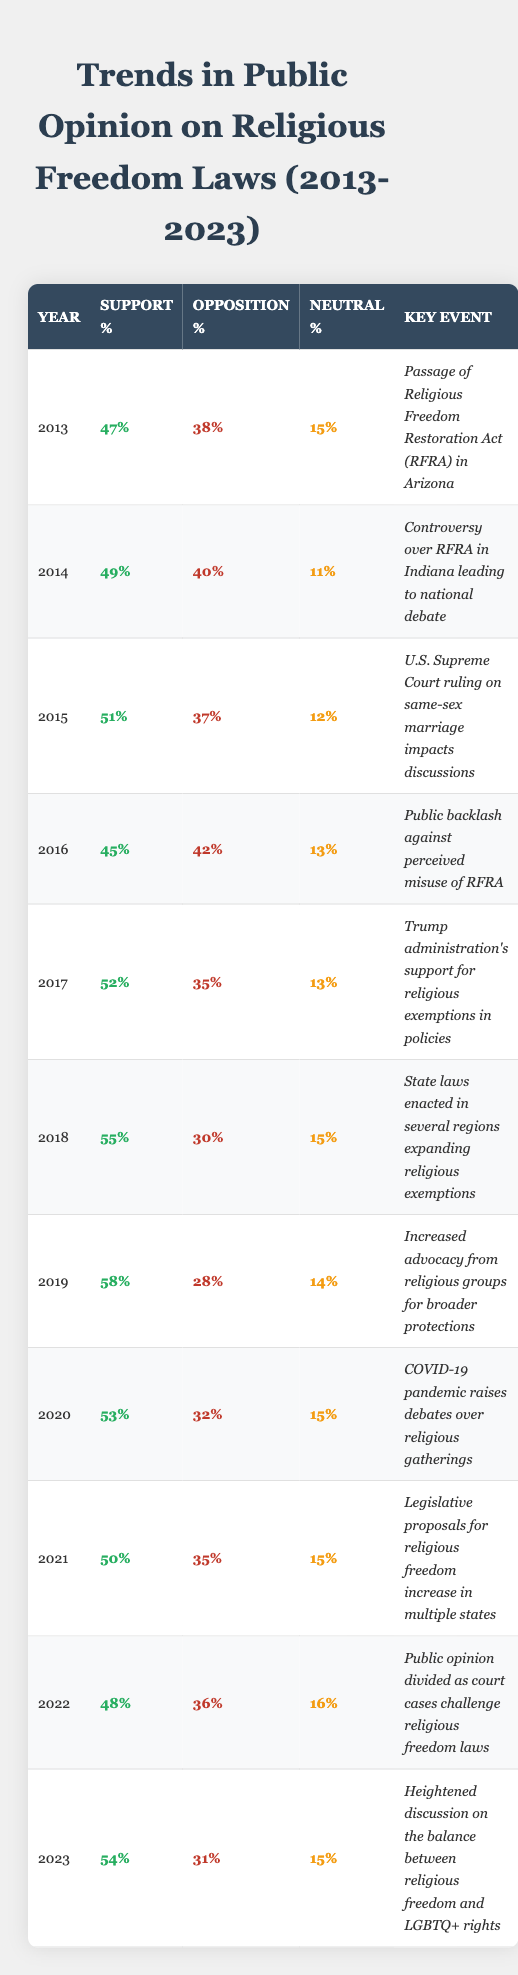What was the support percentage for religious freedom laws in 2013? The table shows that the support percentage for the year 2013 is listed as 47%.
Answer: 47% What was the opposition percentage in 2022? Referring to the table, the opposition percentage for the year 2022 is 36%.
Answer: 36% Which year saw the highest support percentage and what was it? By examining the table, the highest support percentage is found in 2019, at 58%.
Answer: 58% What percentage of people were neutral about religious freedom laws in 2020? The table indicates that the neutral percentage in 2020 was 15%.
Answer: 15% Did support for religious freedom laws decrease from 2015 to 2016? Comparing the support percentages, 2015 had 51% and 2016 had 45%, confirming the decrease.
Answer: Yes What is the average support percentage over the entire decade? To find the average, add all the support percentages: (47 + 49 + 51 + 45 + 52 + 55 + 58 + 53 + 50 + 48 + 54) =  579; divide by 11 (the number of years), which gives 579 / 11 = 52.64. Therefore, the average support is approximately 52%.
Answer: 52% Is there a trend showing a consistent increase in support from 2015 to 2019? In 2015, the support was 51%, which increased to 58% in 2019. Therefore, we can say support consistently rose through that period.
Answer: Yes What was the change in opposition percentage from 2014 to 2018? The opposition percentage in 2014 was 40% and in 2018 it was 30%. Subtracting gives us a decrease of 10%.
Answer: Decrease of 10% How does the support percentage in 2023 compare to the support percentage in 2013? The support percentage in 2023 is 54%, while it was 47% in 2013. Comparing these values shows an increase of 7%.
Answer: Increased by 7% What was the key event in 2016 that affected public opinion on religious freedom laws? The table lists the key event for 2016 as "Public backlash against perceived misuse of RFRA," reflecting significant public sentiment at the time.
Answer: Public backlash against perceived misuse of RFRA How many years had a support percentage of over 50% from 2013 to 2023? By reviewing each year's support percentages, we see that the years 2015, 2017, 2018, 2019, and 2023 had support over 50%. Counting gives a total of 5 years.
Answer: 5 years 